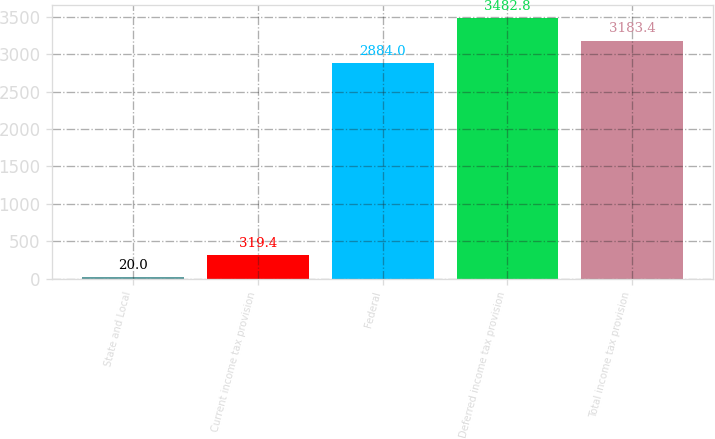Convert chart. <chart><loc_0><loc_0><loc_500><loc_500><bar_chart><fcel>State and Local<fcel>Current income tax provision<fcel>Federal<fcel>Deferred income tax provision<fcel>Total income tax provision<nl><fcel>20<fcel>319.4<fcel>2884<fcel>3482.8<fcel>3183.4<nl></chart> 